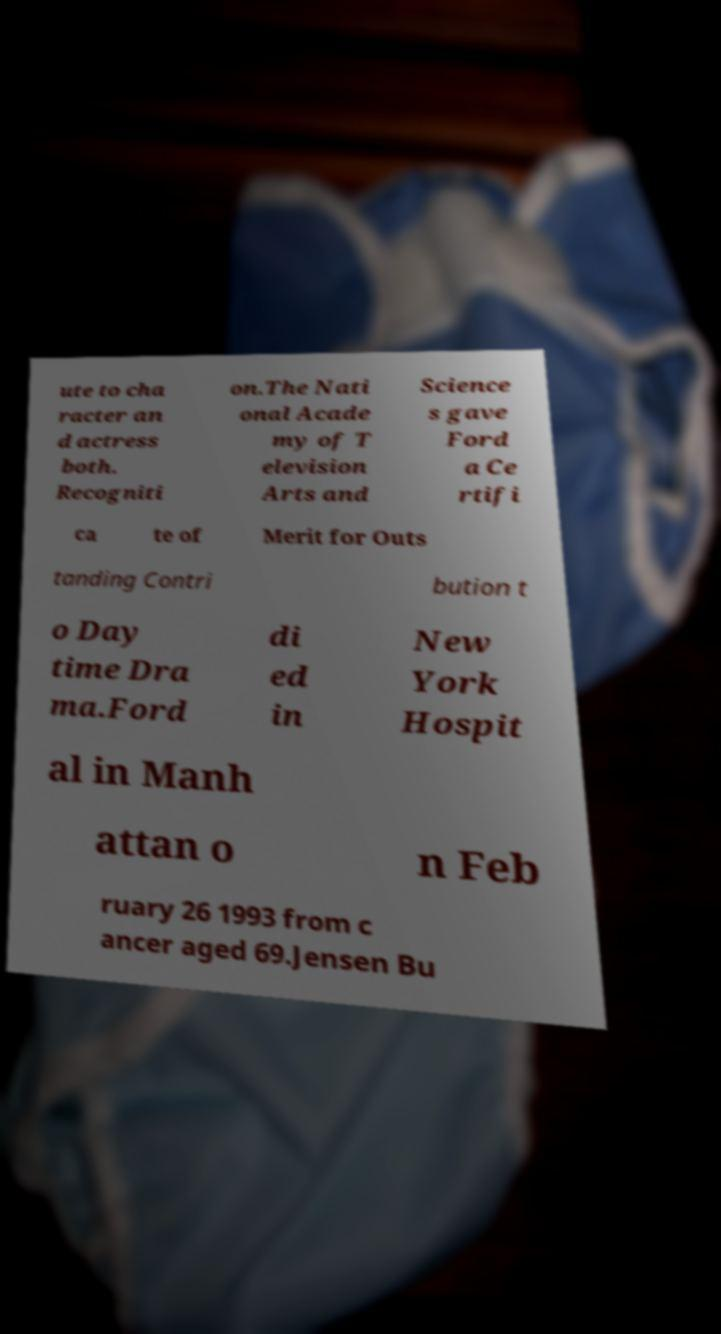I need the written content from this picture converted into text. Can you do that? ute to cha racter an d actress both. Recogniti on.The Nati onal Acade my of T elevision Arts and Science s gave Ford a Ce rtifi ca te of Merit for Outs tanding Contri bution t o Day time Dra ma.Ford di ed in New York Hospit al in Manh attan o n Feb ruary 26 1993 from c ancer aged 69.Jensen Bu 